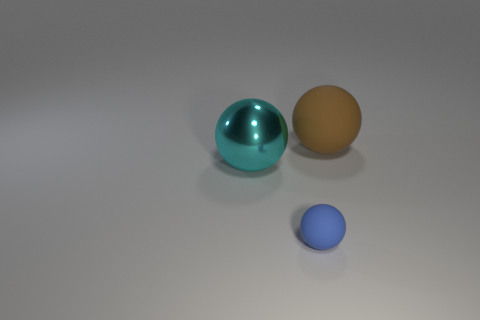Subtract all rubber balls. How many balls are left? 1 Subtract all brown balls. How many balls are left? 2 Subtract 1 spheres. How many spheres are left? 2 Add 1 small blue metallic cylinders. How many objects exist? 4 Subtract all red cubes. How many gray balls are left? 0 Subtract all brown rubber spheres. Subtract all blue spheres. How many objects are left? 1 Add 3 large objects. How many large objects are left? 5 Add 2 brown rubber objects. How many brown rubber objects exist? 3 Subtract 0 gray balls. How many objects are left? 3 Subtract all red spheres. Subtract all gray blocks. How many spheres are left? 3 